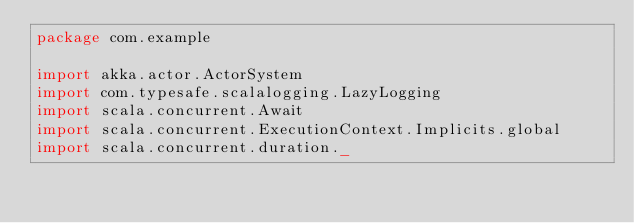Convert code to text. <code><loc_0><loc_0><loc_500><loc_500><_Scala_>package com.example

import akka.actor.ActorSystem
import com.typesafe.scalalogging.LazyLogging
import scala.concurrent.Await
import scala.concurrent.ExecutionContext.Implicits.global
import scala.concurrent.duration._
</code> 